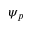<formula> <loc_0><loc_0><loc_500><loc_500>\psi _ { p }</formula> 